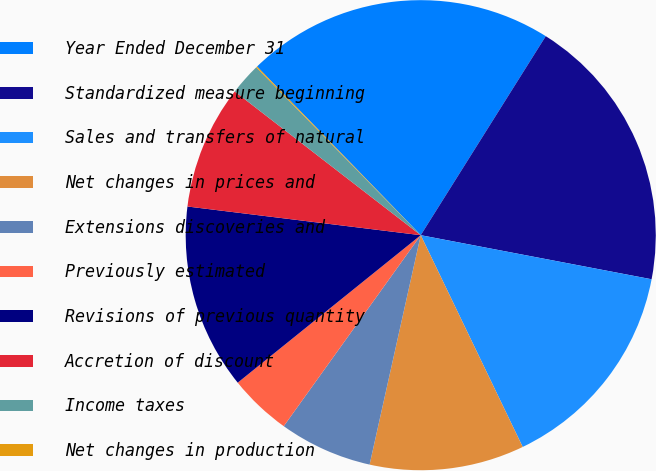Convert chart to OTSL. <chart><loc_0><loc_0><loc_500><loc_500><pie_chart><fcel>Year Ended December 31<fcel>Standardized measure beginning<fcel>Sales and transfers of natural<fcel>Net changes in prices and<fcel>Extensions discoveries and<fcel>Previously estimated<fcel>Revisions of previous quantity<fcel>Accretion of discount<fcel>Income taxes<fcel>Net changes in production<nl><fcel>21.18%<fcel>19.07%<fcel>14.85%<fcel>10.63%<fcel>6.41%<fcel>4.3%<fcel>12.74%<fcel>8.52%<fcel>2.19%<fcel>0.08%<nl></chart> 